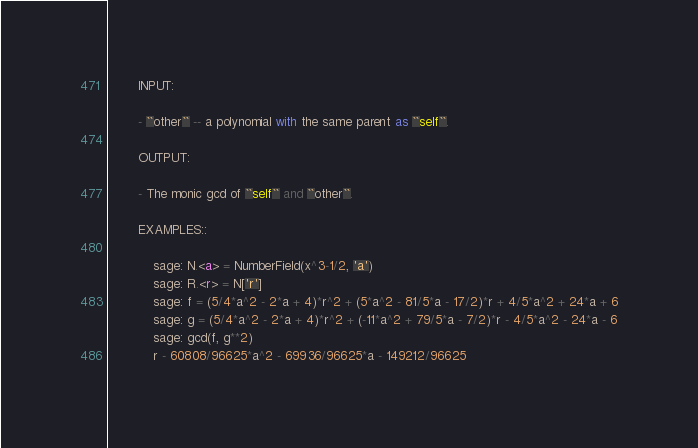Convert code to text. <code><loc_0><loc_0><loc_500><loc_500><_Cython_>        INPUT:

        - ``other`` -- a polynomial with the same parent as ``self``.

        OUTPUT:

        - The monic gcd of ``self`` and ``other``.

        EXAMPLES::

            sage: N.<a> = NumberField(x^3-1/2, 'a')
            sage: R.<r> = N['r']
            sage: f = (5/4*a^2 - 2*a + 4)*r^2 + (5*a^2 - 81/5*a - 17/2)*r + 4/5*a^2 + 24*a + 6
            sage: g = (5/4*a^2 - 2*a + 4)*r^2 + (-11*a^2 + 79/5*a - 7/2)*r - 4/5*a^2 - 24*a - 6
            sage: gcd(f, g**2)
            r - 60808/96625*a^2 - 69936/96625*a - 149212/96625</code> 